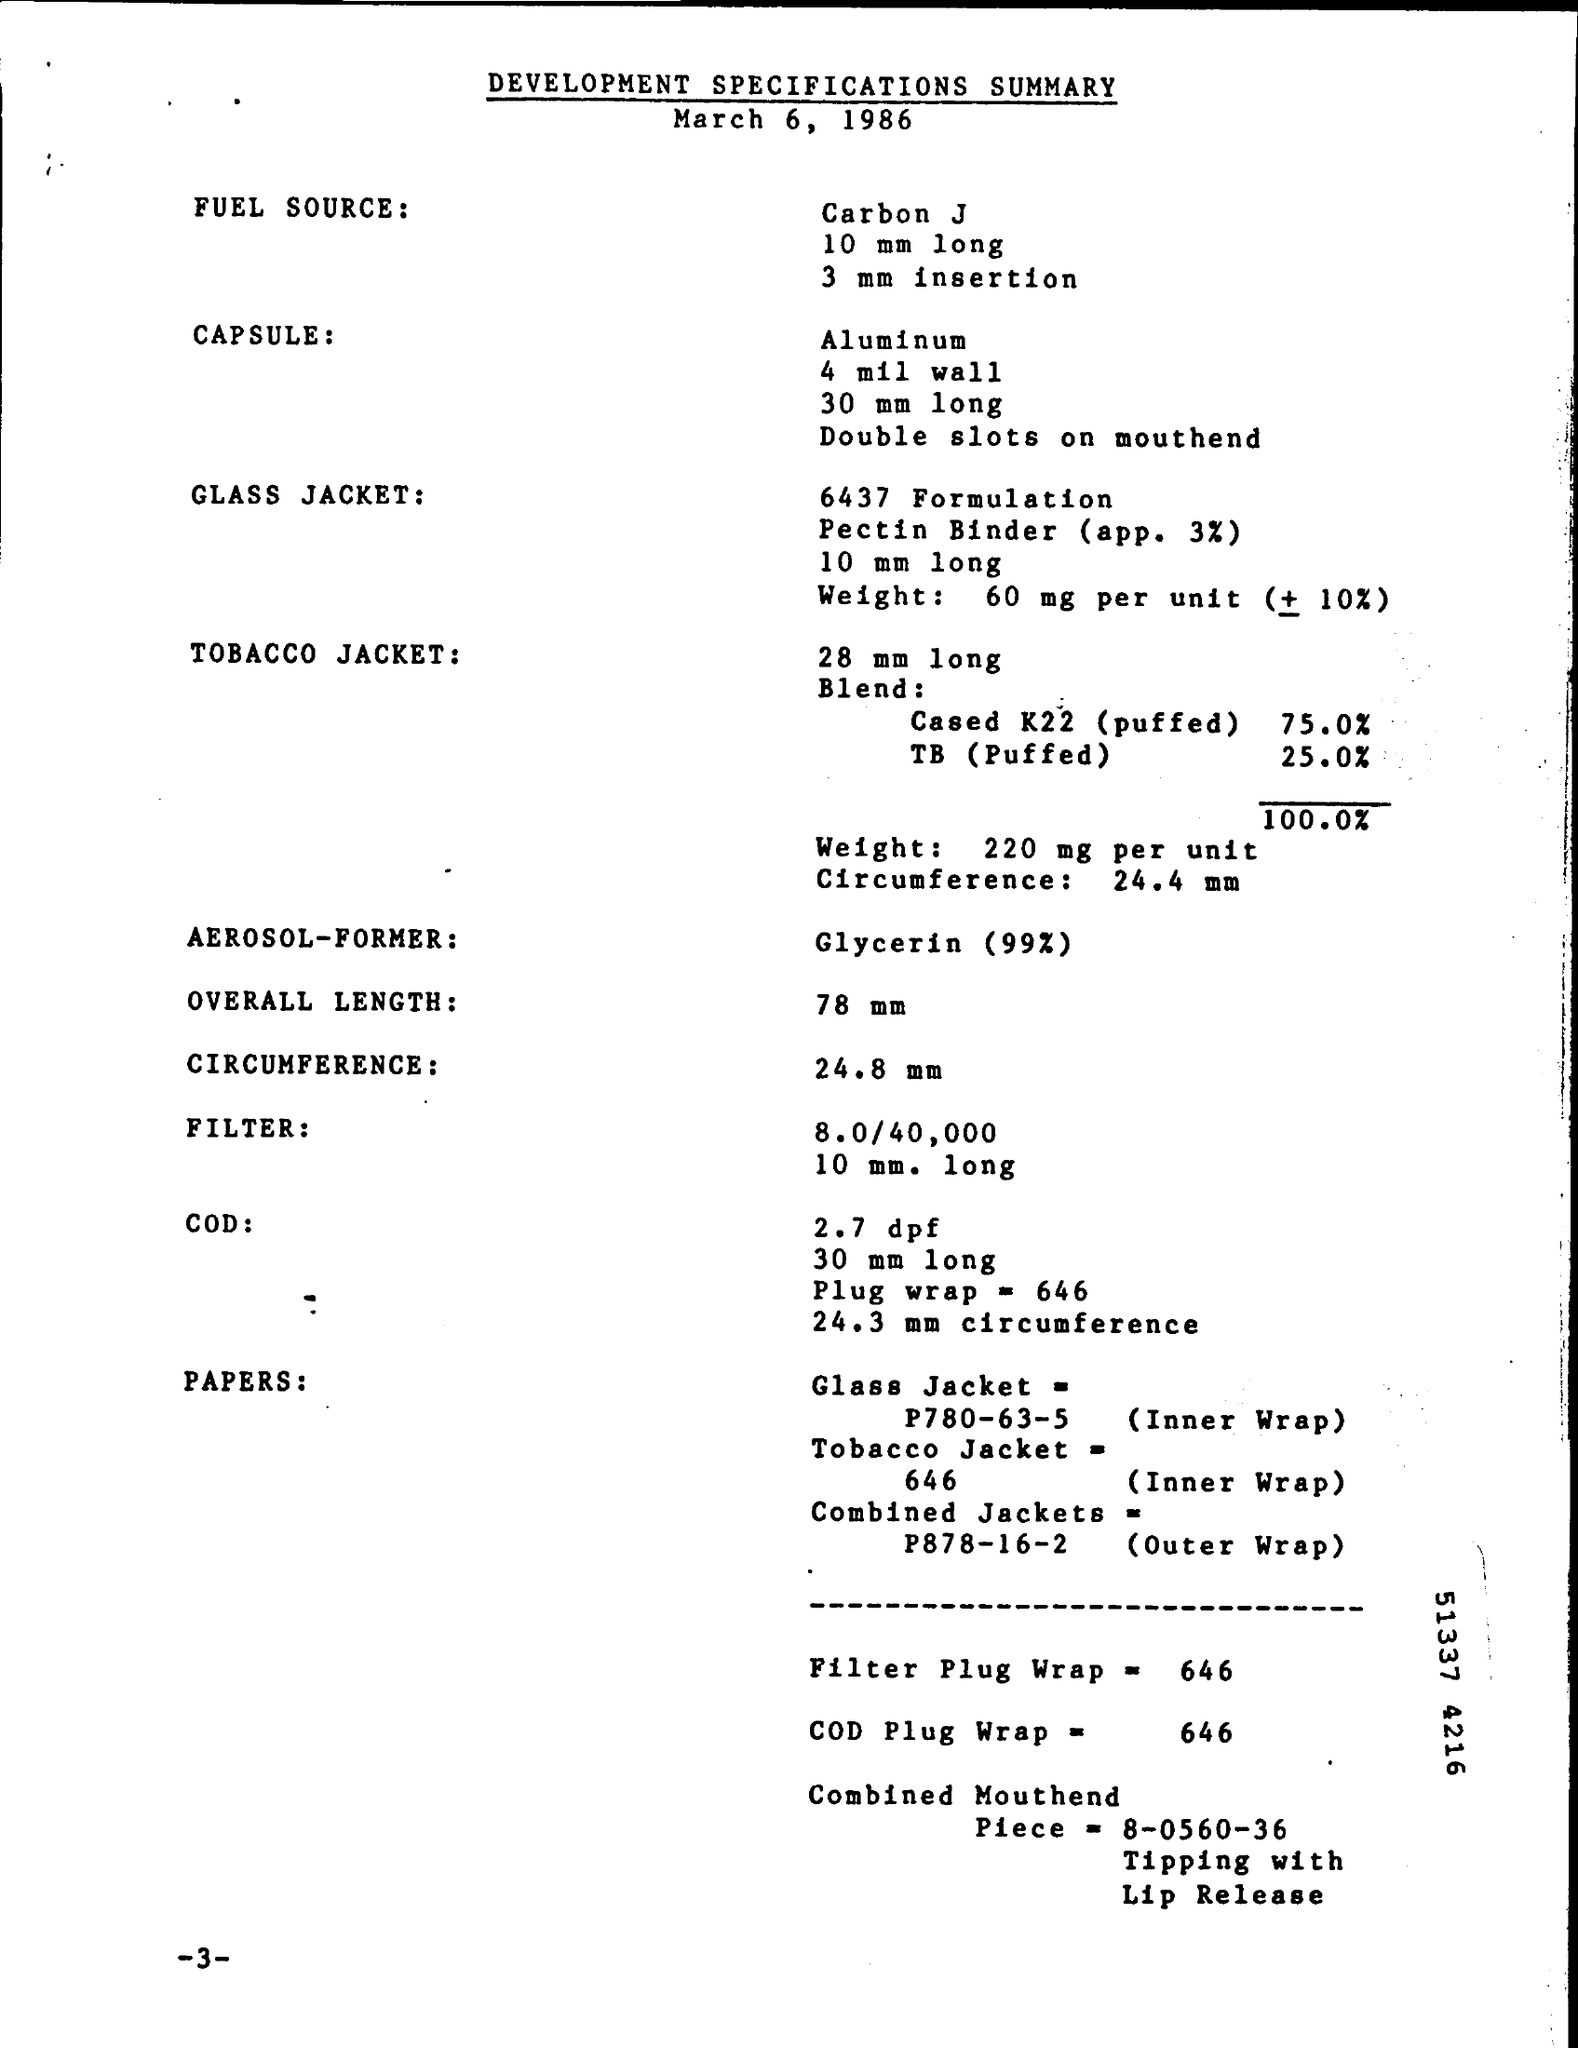What is the fuel source mentioned in the summary ?
Give a very brief answer. Carbon j. What is the length of glass jacket mentioned in the summary ?
Make the answer very short. 10 mm long. What is the weight of tobacco jacket per one unit ?
Your answer should be very brief. 220 mg per unit. What is the circumference of tobacco jacket mentioned in the summary ?
Your answer should be very brief. 24.4 mm. What is the overall length given in the summary ?
Offer a terse response. 78 mm. What is the aerosol former mentioned in the summary ?
Make the answer very short. Glycerin (99%). What is the value of filter plug wrap ?
Give a very brief answer. 646. What is the length of capsule mentioned in the summary ?
Ensure brevity in your answer.  30 mm long. 